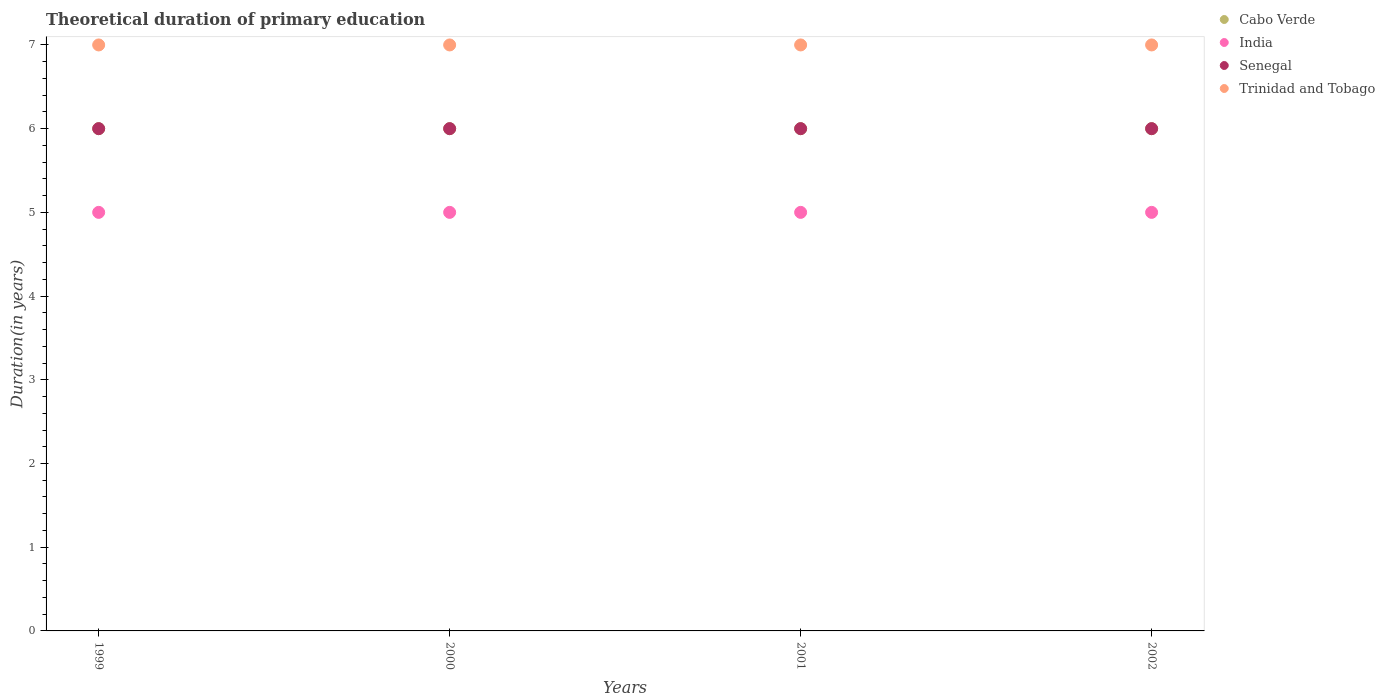How many different coloured dotlines are there?
Make the answer very short. 4. What is the total theoretical duration of primary education in Trinidad and Tobago in 1999?
Keep it short and to the point. 7. Across all years, what is the maximum total theoretical duration of primary education in India?
Give a very brief answer. 5. Across all years, what is the minimum total theoretical duration of primary education in India?
Your response must be concise. 5. In which year was the total theoretical duration of primary education in Cabo Verde minimum?
Make the answer very short. 1999. What is the total total theoretical duration of primary education in Senegal in the graph?
Provide a succinct answer. 24. What is the difference between the total theoretical duration of primary education in Cabo Verde in 2000 and that in 2001?
Offer a terse response. 0. What is the average total theoretical duration of primary education in Cabo Verde per year?
Your answer should be very brief. 6. Is the total theoretical duration of primary education in Senegal in 2000 less than that in 2002?
Provide a succinct answer. No. Is the difference between the total theoretical duration of primary education in Cabo Verde in 1999 and 2002 greater than the difference between the total theoretical duration of primary education in Senegal in 1999 and 2002?
Your answer should be compact. No. What is the difference between the highest and the lowest total theoretical duration of primary education in Senegal?
Your answer should be compact. 0. In how many years, is the total theoretical duration of primary education in India greater than the average total theoretical duration of primary education in India taken over all years?
Make the answer very short. 0. Is the total theoretical duration of primary education in Senegal strictly greater than the total theoretical duration of primary education in India over the years?
Your answer should be very brief. Yes. Is the total theoretical duration of primary education in India strictly less than the total theoretical duration of primary education in Senegal over the years?
Your answer should be very brief. Yes. How many years are there in the graph?
Your answer should be compact. 4. What is the difference between two consecutive major ticks on the Y-axis?
Keep it short and to the point. 1. Are the values on the major ticks of Y-axis written in scientific E-notation?
Offer a terse response. No. Does the graph contain grids?
Offer a terse response. No. Where does the legend appear in the graph?
Your answer should be compact. Top right. How many legend labels are there?
Ensure brevity in your answer.  4. What is the title of the graph?
Keep it short and to the point. Theoretical duration of primary education. What is the label or title of the X-axis?
Your answer should be compact. Years. What is the label or title of the Y-axis?
Give a very brief answer. Duration(in years). What is the Duration(in years) in India in 1999?
Offer a terse response. 5. What is the Duration(in years) in Senegal in 2000?
Your answer should be compact. 6. What is the Duration(in years) in Cabo Verde in 2001?
Provide a succinct answer. 6. What is the Duration(in years) in Senegal in 2001?
Your answer should be very brief. 6. What is the Duration(in years) in Trinidad and Tobago in 2001?
Your response must be concise. 7. What is the Duration(in years) in Senegal in 2002?
Keep it short and to the point. 6. What is the Duration(in years) in Trinidad and Tobago in 2002?
Keep it short and to the point. 7. Across all years, what is the maximum Duration(in years) in Trinidad and Tobago?
Your answer should be very brief. 7. Across all years, what is the minimum Duration(in years) of Senegal?
Provide a short and direct response. 6. Across all years, what is the minimum Duration(in years) of Trinidad and Tobago?
Your response must be concise. 7. What is the total Duration(in years) of India in the graph?
Provide a succinct answer. 20. What is the total Duration(in years) in Trinidad and Tobago in the graph?
Your response must be concise. 28. What is the difference between the Duration(in years) of India in 1999 and that in 2000?
Make the answer very short. 0. What is the difference between the Duration(in years) in India in 1999 and that in 2001?
Provide a short and direct response. 0. What is the difference between the Duration(in years) of Senegal in 1999 and that in 2001?
Ensure brevity in your answer.  0. What is the difference between the Duration(in years) in Cabo Verde in 2000 and that in 2001?
Provide a succinct answer. 0. What is the difference between the Duration(in years) in India in 2000 and that in 2002?
Make the answer very short. 0. What is the difference between the Duration(in years) in Senegal in 2000 and that in 2002?
Your answer should be very brief. 0. What is the difference between the Duration(in years) of Senegal in 2001 and that in 2002?
Offer a terse response. 0. What is the difference between the Duration(in years) of Cabo Verde in 1999 and the Duration(in years) of India in 2000?
Provide a succinct answer. 1. What is the difference between the Duration(in years) in Cabo Verde in 1999 and the Duration(in years) in Senegal in 2000?
Your answer should be compact. 0. What is the difference between the Duration(in years) in India in 1999 and the Duration(in years) in Senegal in 2000?
Provide a short and direct response. -1. What is the difference between the Duration(in years) of Cabo Verde in 1999 and the Duration(in years) of Senegal in 2001?
Offer a very short reply. 0. What is the difference between the Duration(in years) of Cabo Verde in 1999 and the Duration(in years) of Trinidad and Tobago in 2001?
Your answer should be compact. -1. What is the difference between the Duration(in years) of Senegal in 1999 and the Duration(in years) of Trinidad and Tobago in 2001?
Your answer should be compact. -1. What is the difference between the Duration(in years) of Cabo Verde in 1999 and the Duration(in years) of India in 2002?
Ensure brevity in your answer.  1. What is the difference between the Duration(in years) in India in 1999 and the Duration(in years) in Senegal in 2002?
Offer a terse response. -1. What is the difference between the Duration(in years) in Senegal in 1999 and the Duration(in years) in Trinidad and Tobago in 2002?
Your answer should be very brief. -1. What is the difference between the Duration(in years) of Cabo Verde in 2000 and the Duration(in years) of Trinidad and Tobago in 2001?
Give a very brief answer. -1. What is the difference between the Duration(in years) in Cabo Verde in 2000 and the Duration(in years) in India in 2002?
Provide a succinct answer. 1. What is the difference between the Duration(in years) of Cabo Verde in 2000 and the Duration(in years) of Senegal in 2002?
Make the answer very short. 0. What is the difference between the Duration(in years) in India in 2000 and the Duration(in years) in Senegal in 2002?
Provide a short and direct response. -1. What is the difference between the Duration(in years) of India in 2000 and the Duration(in years) of Trinidad and Tobago in 2002?
Offer a terse response. -2. What is the difference between the Duration(in years) of Senegal in 2001 and the Duration(in years) of Trinidad and Tobago in 2002?
Your answer should be compact. -1. What is the average Duration(in years) in Cabo Verde per year?
Offer a terse response. 6. What is the average Duration(in years) of India per year?
Provide a succinct answer. 5. In the year 1999, what is the difference between the Duration(in years) in Cabo Verde and Duration(in years) in India?
Your answer should be compact. 1. In the year 1999, what is the difference between the Duration(in years) in Cabo Verde and Duration(in years) in Senegal?
Provide a succinct answer. 0. In the year 1999, what is the difference between the Duration(in years) in India and Duration(in years) in Senegal?
Offer a terse response. -1. In the year 1999, what is the difference between the Duration(in years) in Senegal and Duration(in years) in Trinidad and Tobago?
Your response must be concise. -1. In the year 2000, what is the difference between the Duration(in years) of Cabo Verde and Duration(in years) of India?
Your response must be concise. 1. In the year 2000, what is the difference between the Duration(in years) of Cabo Verde and Duration(in years) of Trinidad and Tobago?
Make the answer very short. -1. In the year 2000, what is the difference between the Duration(in years) of Senegal and Duration(in years) of Trinidad and Tobago?
Make the answer very short. -1. In the year 2001, what is the difference between the Duration(in years) in Cabo Verde and Duration(in years) in India?
Keep it short and to the point. 1. In the year 2001, what is the difference between the Duration(in years) of Cabo Verde and Duration(in years) of Trinidad and Tobago?
Your answer should be compact. -1. In the year 2002, what is the difference between the Duration(in years) in Cabo Verde and Duration(in years) in India?
Provide a short and direct response. 1. In the year 2002, what is the difference between the Duration(in years) of Cabo Verde and Duration(in years) of Trinidad and Tobago?
Offer a very short reply. -1. In the year 2002, what is the difference between the Duration(in years) of India and Duration(in years) of Senegal?
Your response must be concise. -1. In the year 2002, what is the difference between the Duration(in years) of India and Duration(in years) of Trinidad and Tobago?
Offer a terse response. -2. What is the ratio of the Duration(in years) of India in 1999 to that in 2000?
Offer a very short reply. 1. What is the ratio of the Duration(in years) of Trinidad and Tobago in 1999 to that in 2000?
Make the answer very short. 1. What is the ratio of the Duration(in years) of India in 1999 to that in 2001?
Ensure brevity in your answer.  1. What is the ratio of the Duration(in years) of Senegal in 1999 to that in 2001?
Your response must be concise. 1. What is the ratio of the Duration(in years) in Trinidad and Tobago in 1999 to that in 2001?
Make the answer very short. 1. What is the ratio of the Duration(in years) in Cabo Verde in 1999 to that in 2002?
Your answer should be very brief. 1. What is the ratio of the Duration(in years) of India in 1999 to that in 2002?
Make the answer very short. 1. What is the ratio of the Duration(in years) of Cabo Verde in 2000 to that in 2001?
Your answer should be very brief. 1. What is the ratio of the Duration(in years) in Trinidad and Tobago in 2000 to that in 2001?
Your answer should be very brief. 1. What is the ratio of the Duration(in years) in Cabo Verde in 2000 to that in 2002?
Keep it short and to the point. 1. What is the ratio of the Duration(in years) in India in 2000 to that in 2002?
Your answer should be compact. 1. What is the ratio of the Duration(in years) of India in 2001 to that in 2002?
Provide a succinct answer. 1. What is the ratio of the Duration(in years) of Senegal in 2001 to that in 2002?
Give a very brief answer. 1. What is the ratio of the Duration(in years) in Trinidad and Tobago in 2001 to that in 2002?
Provide a succinct answer. 1. What is the difference between the highest and the second highest Duration(in years) in Cabo Verde?
Your answer should be very brief. 0. What is the difference between the highest and the lowest Duration(in years) in Senegal?
Your answer should be compact. 0. 